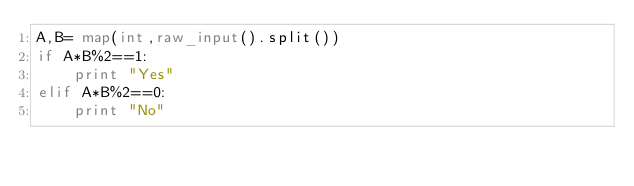Convert code to text. <code><loc_0><loc_0><loc_500><loc_500><_Python_>A,B= map(int,raw_input().split())
if A*B%2==1:
    print "Yes"
elif A*B%2==0:
    print "No"
    </code> 